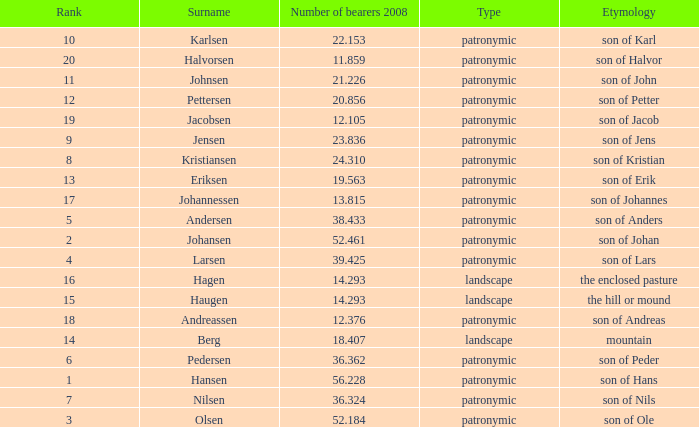What is Etymology, when Rank is 14? Mountain. 